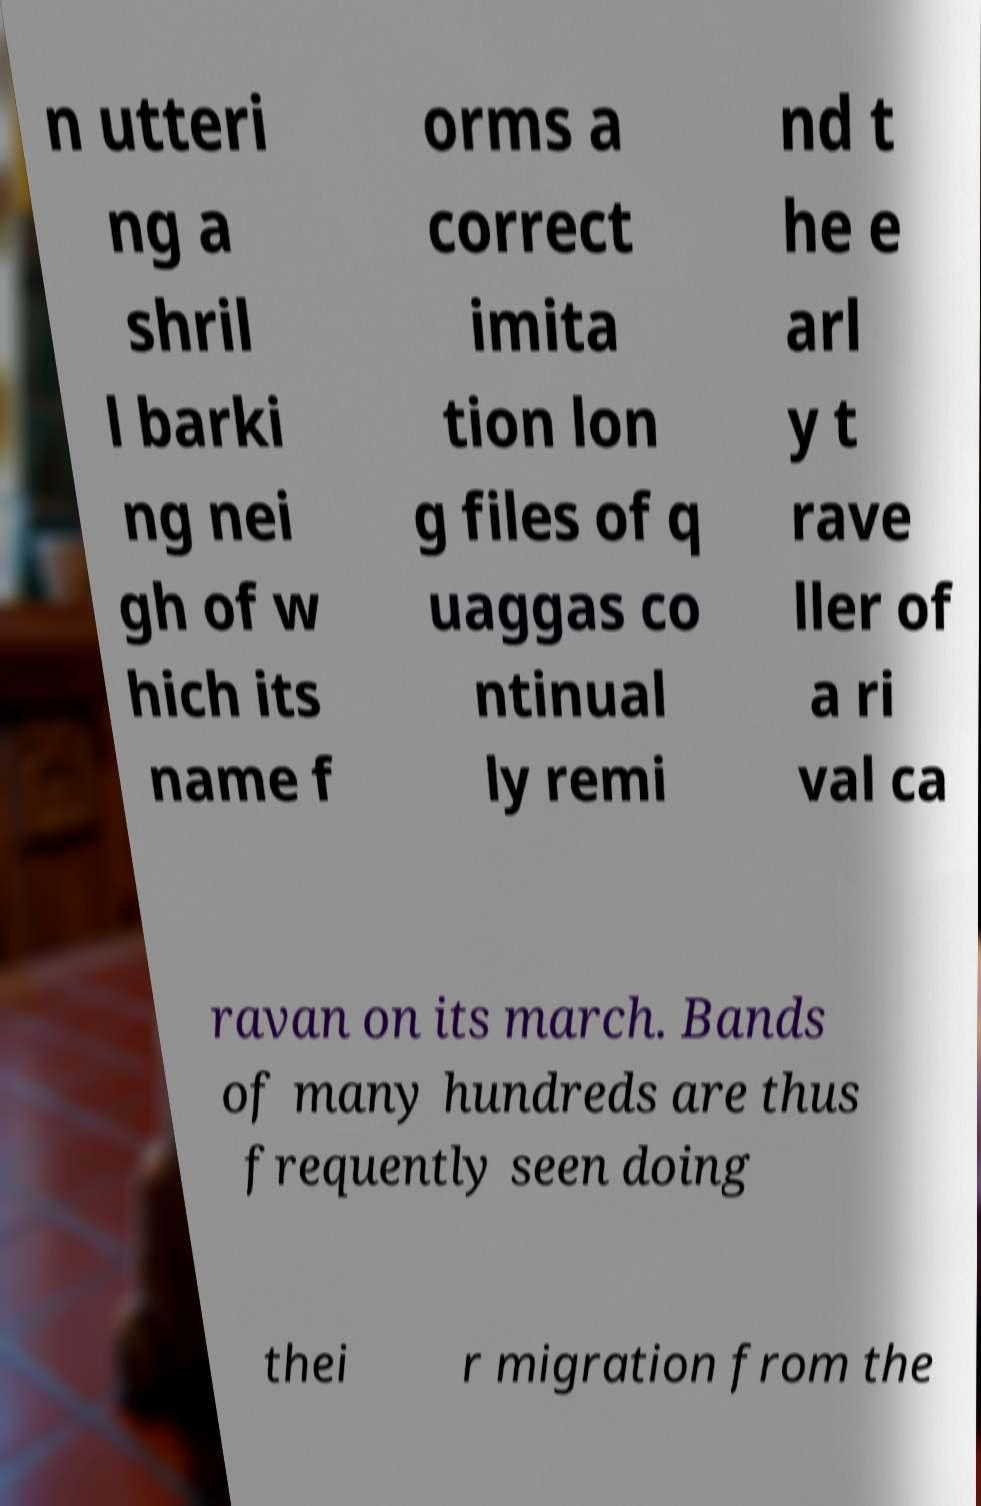For documentation purposes, I need the text within this image transcribed. Could you provide that? n utteri ng a shril l barki ng nei gh of w hich its name f orms a correct imita tion lon g files of q uaggas co ntinual ly remi nd t he e arl y t rave ller of a ri val ca ravan on its march. Bands of many hundreds are thus frequently seen doing thei r migration from the 